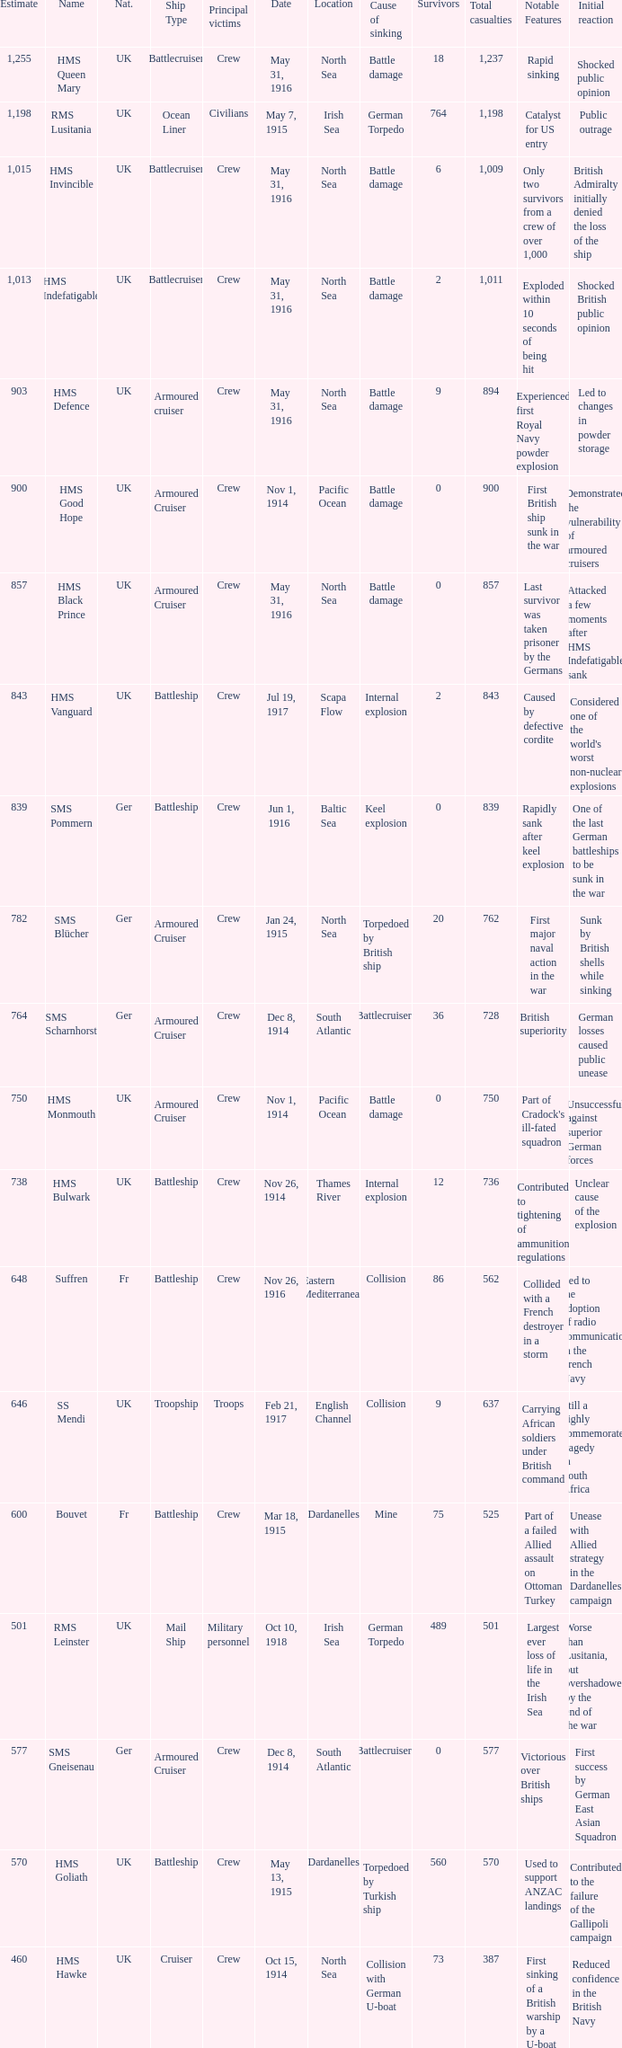What is the name of the battleship with the battle listed on may 13, 1915? HMS Goliath. 